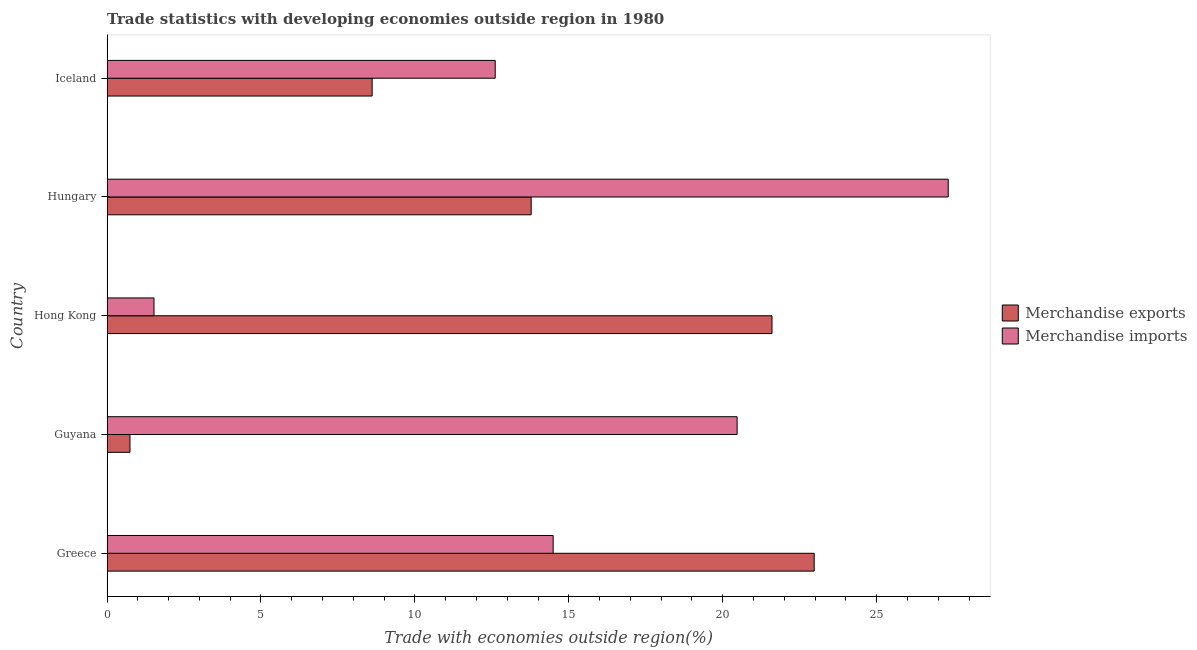How many different coloured bars are there?
Give a very brief answer. 2. Are the number of bars per tick equal to the number of legend labels?
Provide a short and direct response. Yes. Are the number of bars on each tick of the Y-axis equal?
Ensure brevity in your answer.  Yes. How many bars are there on the 2nd tick from the top?
Your answer should be very brief. 2. How many bars are there on the 4th tick from the bottom?
Give a very brief answer. 2. What is the label of the 2nd group of bars from the top?
Offer a very short reply. Hungary. In how many cases, is the number of bars for a given country not equal to the number of legend labels?
Make the answer very short. 0. What is the merchandise exports in Hong Kong?
Offer a very short reply. 21.6. Across all countries, what is the maximum merchandise exports?
Offer a very short reply. 22.97. Across all countries, what is the minimum merchandise imports?
Offer a very short reply. 1.53. In which country was the merchandise imports minimum?
Offer a terse response. Hong Kong. What is the total merchandise exports in the graph?
Offer a terse response. 67.7. What is the difference between the merchandise exports in Greece and that in Iceland?
Provide a short and direct response. 14.36. What is the difference between the merchandise imports in Guyana and the merchandise exports in Iceland?
Provide a succinct answer. 11.85. What is the average merchandise imports per country?
Ensure brevity in your answer.  15.28. What is the difference between the merchandise exports and merchandise imports in Iceland?
Your response must be concise. -4. What is the ratio of the merchandise exports in Greece to that in Hungary?
Offer a terse response. 1.67. Is the merchandise exports in Greece less than that in Hungary?
Provide a succinct answer. No. Is the difference between the merchandise imports in Greece and Iceland greater than the difference between the merchandise exports in Greece and Iceland?
Offer a terse response. No. What is the difference between the highest and the second highest merchandise imports?
Offer a very short reply. 6.86. What is the difference between the highest and the lowest merchandise imports?
Your answer should be very brief. 25.8. What does the 1st bar from the top in Iceland represents?
Your answer should be very brief. Merchandise imports. How many bars are there?
Your answer should be very brief. 10. Are all the bars in the graph horizontal?
Your response must be concise. Yes. What is the difference between two consecutive major ticks on the X-axis?
Your answer should be compact. 5. Are the values on the major ticks of X-axis written in scientific E-notation?
Your answer should be compact. No. Does the graph contain any zero values?
Your answer should be very brief. No. Where does the legend appear in the graph?
Your answer should be very brief. Center right. How many legend labels are there?
Offer a very short reply. 2. What is the title of the graph?
Provide a succinct answer. Trade statistics with developing economies outside region in 1980. Does "Lower secondary education" appear as one of the legend labels in the graph?
Your answer should be very brief. No. What is the label or title of the X-axis?
Your answer should be very brief. Trade with economies outside region(%). What is the Trade with economies outside region(%) in Merchandise exports in Greece?
Keep it short and to the point. 22.97. What is the Trade with economies outside region(%) in Merchandise imports in Greece?
Offer a terse response. 14.49. What is the Trade with economies outside region(%) in Merchandise exports in Guyana?
Offer a terse response. 0.75. What is the Trade with economies outside region(%) of Merchandise imports in Guyana?
Provide a short and direct response. 20.47. What is the Trade with economies outside region(%) in Merchandise exports in Hong Kong?
Give a very brief answer. 21.6. What is the Trade with economies outside region(%) in Merchandise imports in Hong Kong?
Give a very brief answer. 1.53. What is the Trade with economies outside region(%) of Merchandise exports in Hungary?
Your response must be concise. 13.78. What is the Trade with economies outside region(%) in Merchandise imports in Hungary?
Give a very brief answer. 27.32. What is the Trade with economies outside region(%) in Merchandise exports in Iceland?
Give a very brief answer. 8.61. What is the Trade with economies outside region(%) of Merchandise imports in Iceland?
Your answer should be very brief. 12.61. Across all countries, what is the maximum Trade with economies outside region(%) in Merchandise exports?
Offer a terse response. 22.97. Across all countries, what is the maximum Trade with economies outside region(%) of Merchandise imports?
Ensure brevity in your answer.  27.32. Across all countries, what is the minimum Trade with economies outside region(%) in Merchandise exports?
Provide a succinct answer. 0.75. Across all countries, what is the minimum Trade with economies outside region(%) of Merchandise imports?
Your answer should be very brief. 1.53. What is the total Trade with economies outside region(%) of Merchandise exports in the graph?
Provide a short and direct response. 67.7. What is the total Trade with economies outside region(%) of Merchandise imports in the graph?
Offer a very short reply. 76.42. What is the difference between the Trade with economies outside region(%) in Merchandise exports in Greece and that in Guyana?
Provide a succinct answer. 22.22. What is the difference between the Trade with economies outside region(%) in Merchandise imports in Greece and that in Guyana?
Your answer should be compact. -5.98. What is the difference between the Trade with economies outside region(%) of Merchandise exports in Greece and that in Hong Kong?
Provide a succinct answer. 1.37. What is the difference between the Trade with economies outside region(%) of Merchandise imports in Greece and that in Hong Kong?
Give a very brief answer. 12.96. What is the difference between the Trade with economies outside region(%) in Merchandise exports in Greece and that in Hungary?
Provide a short and direct response. 9.19. What is the difference between the Trade with economies outside region(%) in Merchandise imports in Greece and that in Hungary?
Provide a succinct answer. -12.83. What is the difference between the Trade with economies outside region(%) of Merchandise exports in Greece and that in Iceland?
Provide a short and direct response. 14.36. What is the difference between the Trade with economies outside region(%) of Merchandise imports in Greece and that in Iceland?
Keep it short and to the point. 1.88. What is the difference between the Trade with economies outside region(%) in Merchandise exports in Guyana and that in Hong Kong?
Offer a very short reply. -20.85. What is the difference between the Trade with economies outside region(%) of Merchandise imports in Guyana and that in Hong Kong?
Your answer should be very brief. 18.94. What is the difference between the Trade with economies outside region(%) of Merchandise exports in Guyana and that in Hungary?
Your answer should be very brief. -13.03. What is the difference between the Trade with economies outside region(%) of Merchandise imports in Guyana and that in Hungary?
Offer a terse response. -6.86. What is the difference between the Trade with economies outside region(%) of Merchandise exports in Guyana and that in Iceland?
Offer a terse response. -7.87. What is the difference between the Trade with economies outside region(%) in Merchandise imports in Guyana and that in Iceland?
Offer a terse response. 7.86. What is the difference between the Trade with economies outside region(%) of Merchandise exports in Hong Kong and that in Hungary?
Give a very brief answer. 7.82. What is the difference between the Trade with economies outside region(%) of Merchandise imports in Hong Kong and that in Hungary?
Offer a very short reply. -25.8. What is the difference between the Trade with economies outside region(%) of Merchandise exports in Hong Kong and that in Iceland?
Provide a short and direct response. 12.99. What is the difference between the Trade with economies outside region(%) of Merchandise imports in Hong Kong and that in Iceland?
Your response must be concise. -11.08. What is the difference between the Trade with economies outside region(%) in Merchandise exports in Hungary and that in Iceland?
Provide a succinct answer. 5.17. What is the difference between the Trade with economies outside region(%) in Merchandise imports in Hungary and that in Iceland?
Your answer should be very brief. 14.71. What is the difference between the Trade with economies outside region(%) of Merchandise exports in Greece and the Trade with economies outside region(%) of Merchandise imports in Guyana?
Provide a succinct answer. 2.5. What is the difference between the Trade with economies outside region(%) in Merchandise exports in Greece and the Trade with economies outside region(%) in Merchandise imports in Hong Kong?
Your answer should be compact. 21.44. What is the difference between the Trade with economies outside region(%) in Merchandise exports in Greece and the Trade with economies outside region(%) in Merchandise imports in Hungary?
Give a very brief answer. -4.35. What is the difference between the Trade with economies outside region(%) of Merchandise exports in Greece and the Trade with economies outside region(%) of Merchandise imports in Iceland?
Keep it short and to the point. 10.36. What is the difference between the Trade with economies outside region(%) in Merchandise exports in Guyana and the Trade with economies outside region(%) in Merchandise imports in Hong Kong?
Provide a short and direct response. -0.78. What is the difference between the Trade with economies outside region(%) of Merchandise exports in Guyana and the Trade with economies outside region(%) of Merchandise imports in Hungary?
Offer a terse response. -26.58. What is the difference between the Trade with economies outside region(%) in Merchandise exports in Guyana and the Trade with economies outside region(%) in Merchandise imports in Iceland?
Provide a short and direct response. -11.86. What is the difference between the Trade with economies outside region(%) in Merchandise exports in Hong Kong and the Trade with economies outside region(%) in Merchandise imports in Hungary?
Ensure brevity in your answer.  -5.72. What is the difference between the Trade with economies outside region(%) of Merchandise exports in Hong Kong and the Trade with economies outside region(%) of Merchandise imports in Iceland?
Provide a succinct answer. 8.99. What is the difference between the Trade with economies outside region(%) in Merchandise exports in Hungary and the Trade with economies outside region(%) in Merchandise imports in Iceland?
Your response must be concise. 1.17. What is the average Trade with economies outside region(%) in Merchandise exports per country?
Keep it short and to the point. 13.54. What is the average Trade with economies outside region(%) in Merchandise imports per country?
Your answer should be very brief. 15.28. What is the difference between the Trade with economies outside region(%) of Merchandise exports and Trade with economies outside region(%) of Merchandise imports in Greece?
Your answer should be compact. 8.48. What is the difference between the Trade with economies outside region(%) in Merchandise exports and Trade with economies outside region(%) in Merchandise imports in Guyana?
Provide a succinct answer. -19.72. What is the difference between the Trade with economies outside region(%) of Merchandise exports and Trade with economies outside region(%) of Merchandise imports in Hong Kong?
Make the answer very short. 20.07. What is the difference between the Trade with economies outside region(%) in Merchandise exports and Trade with economies outside region(%) in Merchandise imports in Hungary?
Keep it short and to the point. -13.55. What is the difference between the Trade with economies outside region(%) in Merchandise exports and Trade with economies outside region(%) in Merchandise imports in Iceland?
Your answer should be compact. -4. What is the ratio of the Trade with economies outside region(%) of Merchandise exports in Greece to that in Guyana?
Make the answer very short. 30.8. What is the ratio of the Trade with economies outside region(%) of Merchandise imports in Greece to that in Guyana?
Your response must be concise. 0.71. What is the ratio of the Trade with economies outside region(%) of Merchandise exports in Greece to that in Hong Kong?
Offer a very short reply. 1.06. What is the ratio of the Trade with economies outside region(%) in Merchandise imports in Greece to that in Hong Kong?
Keep it short and to the point. 9.49. What is the ratio of the Trade with economies outside region(%) of Merchandise exports in Greece to that in Hungary?
Give a very brief answer. 1.67. What is the ratio of the Trade with economies outside region(%) in Merchandise imports in Greece to that in Hungary?
Provide a short and direct response. 0.53. What is the ratio of the Trade with economies outside region(%) in Merchandise exports in Greece to that in Iceland?
Offer a very short reply. 2.67. What is the ratio of the Trade with economies outside region(%) of Merchandise imports in Greece to that in Iceland?
Provide a succinct answer. 1.15. What is the ratio of the Trade with economies outside region(%) of Merchandise exports in Guyana to that in Hong Kong?
Offer a very short reply. 0.03. What is the ratio of the Trade with economies outside region(%) of Merchandise imports in Guyana to that in Hong Kong?
Provide a succinct answer. 13.41. What is the ratio of the Trade with economies outside region(%) in Merchandise exports in Guyana to that in Hungary?
Ensure brevity in your answer.  0.05. What is the ratio of the Trade with economies outside region(%) in Merchandise imports in Guyana to that in Hungary?
Your response must be concise. 0.75. What is the ratio of the Trade with economies outside region(%) of Merchandise exports in Guyana to that in Iceland?
Offer a terse response. 0.09. What is the ratio of the Trade with economies outside region(%) of Merchandise imports in Guyana to that in Iceland?
Ensure brevity in your answer.  1.62. What is the ratio of the Trade with economies outside region(%) of Merchandise exports in Hong Kong to that in Hungary?
Provide a succinct answer. 1.57. What is the ratio of the Trade with economies outside region(%) of Merchandise imports in Hong Kong to that in Hungary?
Provide a short and direct response. 0.06. What is the ratio of the Trade with economies outside region(%) of Merchandise exports in Hong Kong to that in Iceland?
Ensure brevity in your answer.  2.51. What is the ratio of the Trade with economies outside region(%) in Merchandise imports in Hong Kong to that in Iceland?
Provide a succinct answer. 0.12. What is the ratio of the Trade with economies outside region(%) in Merchandise exports in Hungary to that in Iceland?
Your response must be concise. 1.6. What is the ratio of the Trade with economies outside region(%) of Merchandise imports in Hungary to that in Iceland?
Ensure brevity in your answer.  2.17. What is the difference between the highest and the second highest Trade with economies outside region(%) of Merchandise exports?
Make the answer very short. 1.37. What is the difference between the highest and the second highest Trade with economies outside region(%) of Merchandise imports?
Provide a short and direct response. 6.86. What is the difference between the highest and the lowest Trade with economies outside region(%) of Merchandise exports?
Offer a terse response. 22.22. What is the difference between the highest and the lowest Trade with economies outside region(%) of Merchandise imports?
Offer a terse response. 25.8. 